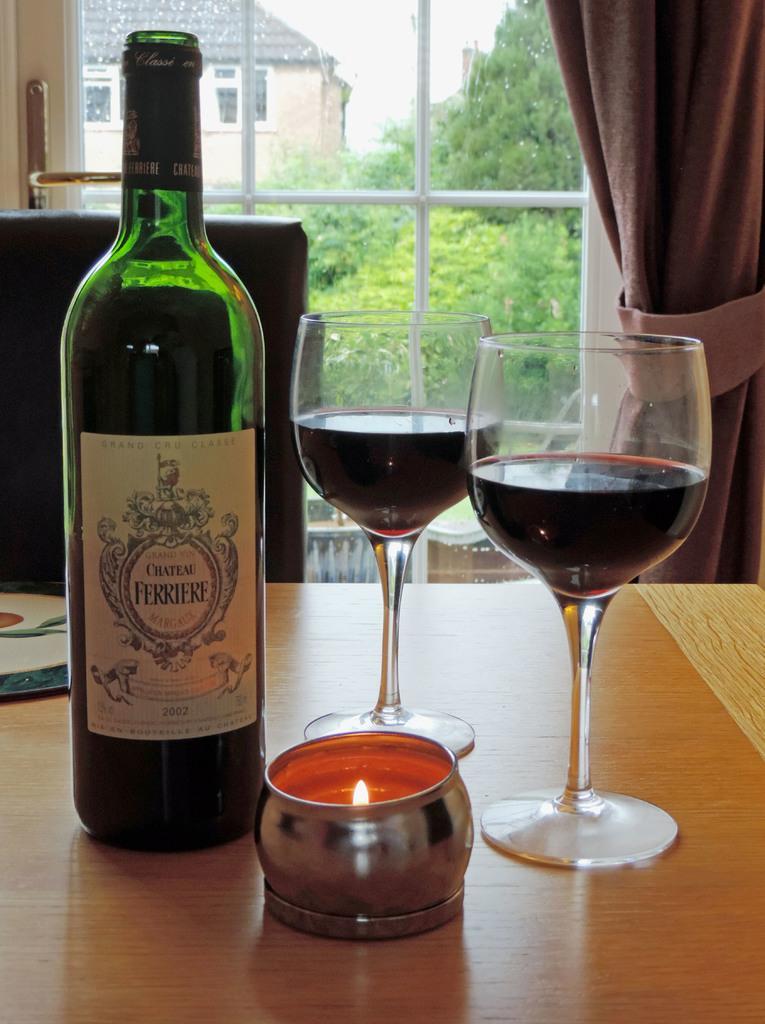In one or two sentences, can you explain what this image depicts? In this picture I can see a table in front on which there are 2 glasses and a bottle and I see small container in which I see the light and in the background I see the window, beside the window I see the curtain and through the window I see a building and number of plants. 